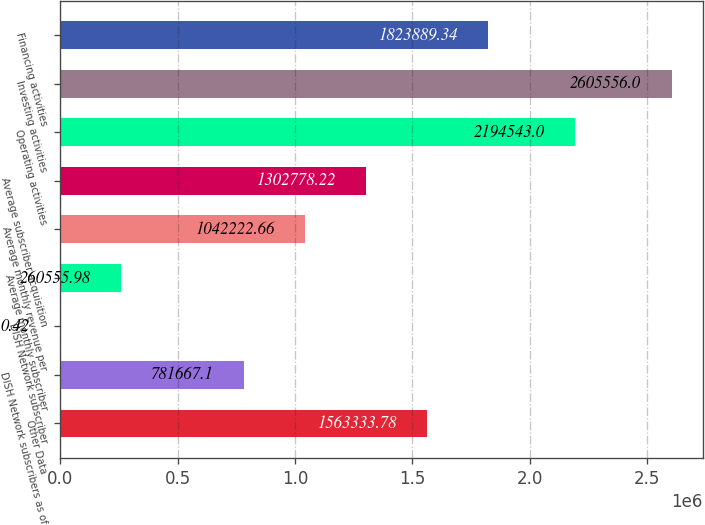Convert chart. <chart><loc_0><loc_0><loc_500><loc_500><bar_chart><fcel>Other Data<fcel>DISH Network subscribers as of<fcel>DISH Network subscriber<fcel>Average monthly subscriber<fcel>Average monthly revenue per<fcel>Average subscriber acquisition<fcel>Operating activities<fcel>Investing activities<fcel>Financing activities<nl><fcel>1.56333e+06<fcel>781667<fcel>0.42<fcel>260556<fcel>1.04222e+06<fcel>1.30278e+06<fcel>2.19454e+06<fcel>2.60556e+06<fcel>1.82389e+06<nl></chart> 